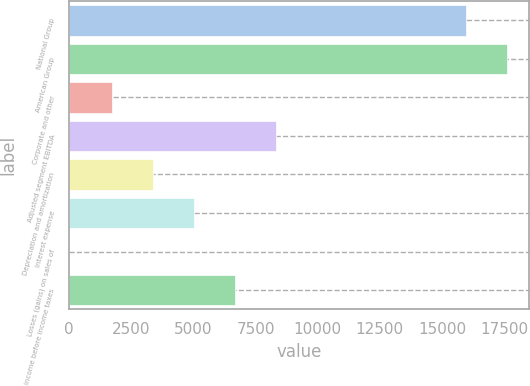<chart> <loc_0><loc_0><loc_500><loc_500><bar_chart><fcel>National Group<fcel>American Group<fcel>Corporate and other<fcel>Adjusted segment EBITDA<fcel>Depreciation and amortization<fcel>Interest expense<fcel>Losses (gains) on sales of<fcel>Income before income taxes<nl><fcel>15968<fcel>17615.7<fcel>1727<fcel>8317.8<fcel>3374.7<fcel>5022.4<fcel>10<fcel>6670.1<nl></chart> 